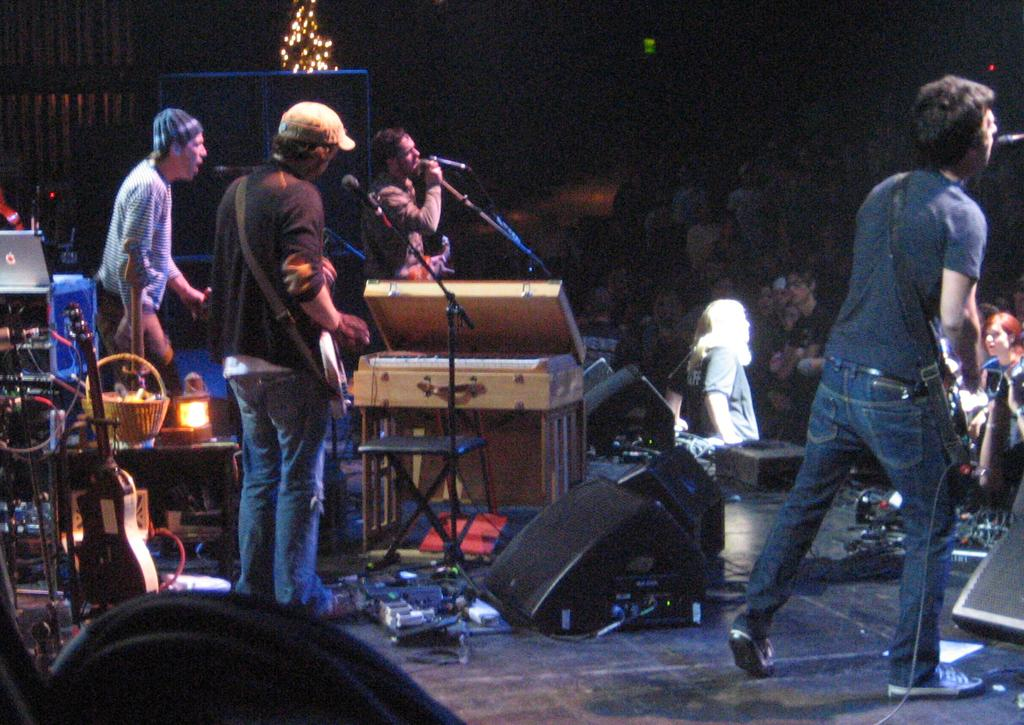What is the main activity taking place in the image? There are persons standing in the image, and they are part of an audience. What objects are present that might be related to the activity? There is a microphone with a stand and some people are holding guitars. What type of instruments can be seen in the image? There are musical instruments in the image. What can be seen at the top of the image? There are lights visible at the top of the image. How many ladybugs can be seen crawling on the microphone stand in the image? There are no ladybugs present in the image; the focus is on the audience, musical instruments, and lights. 